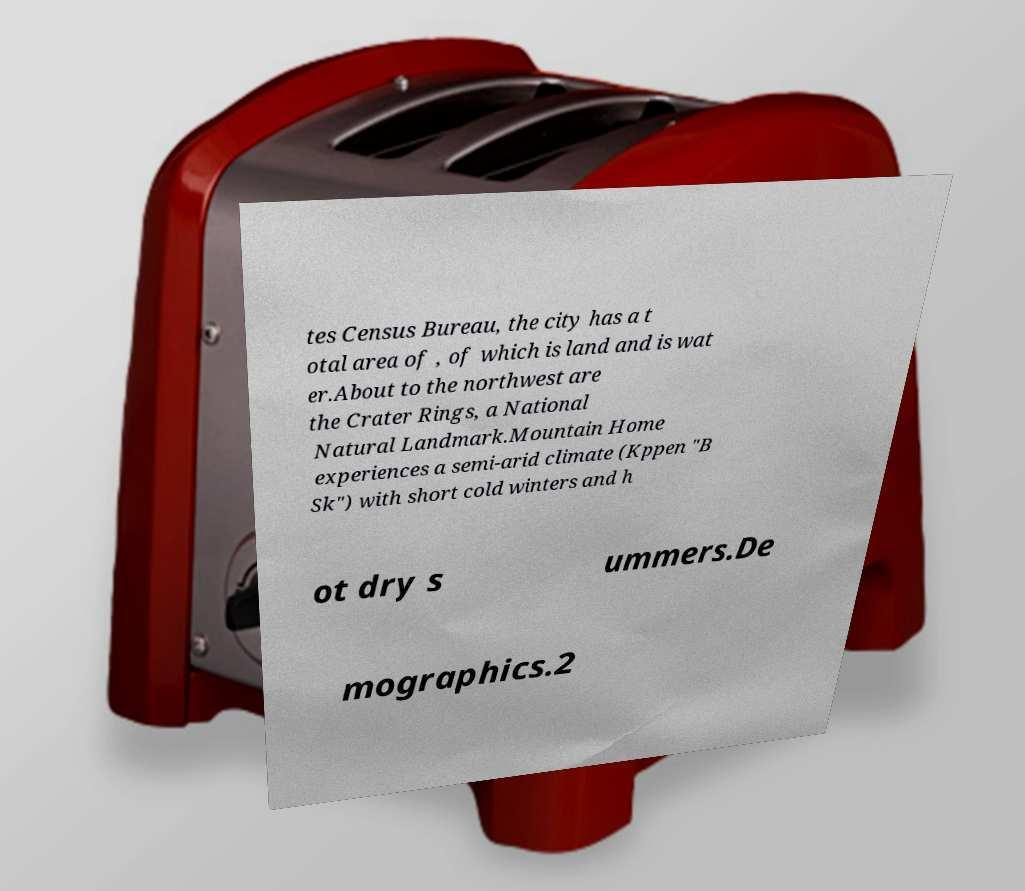What messages or text are displayed in this image? I need them in a readable, typed format. tes Census Bureau, the city has a t otal area of , of which is land and is wat er.About to the northwest are the Crater Rings, a National Natural Landmark.Mountain Home experiences a semi-arid climate (Kppen "B Sk") with short cold winters and h ot dry s ummers.De mographics.2 